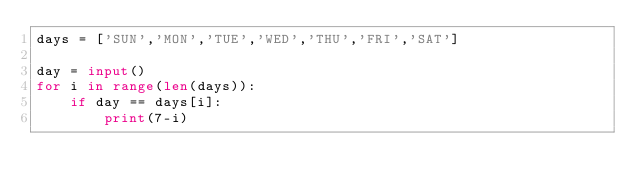Convert code to text. <code><loc_0><loc_0><loc_500><loc_500><_Python_>days = ['SUN','MON','TUE','WED','THU','FRI','SAT']

day = input()
for i in range(len(days)):
    if day == days[i]:
        print(7-i)
</code> 